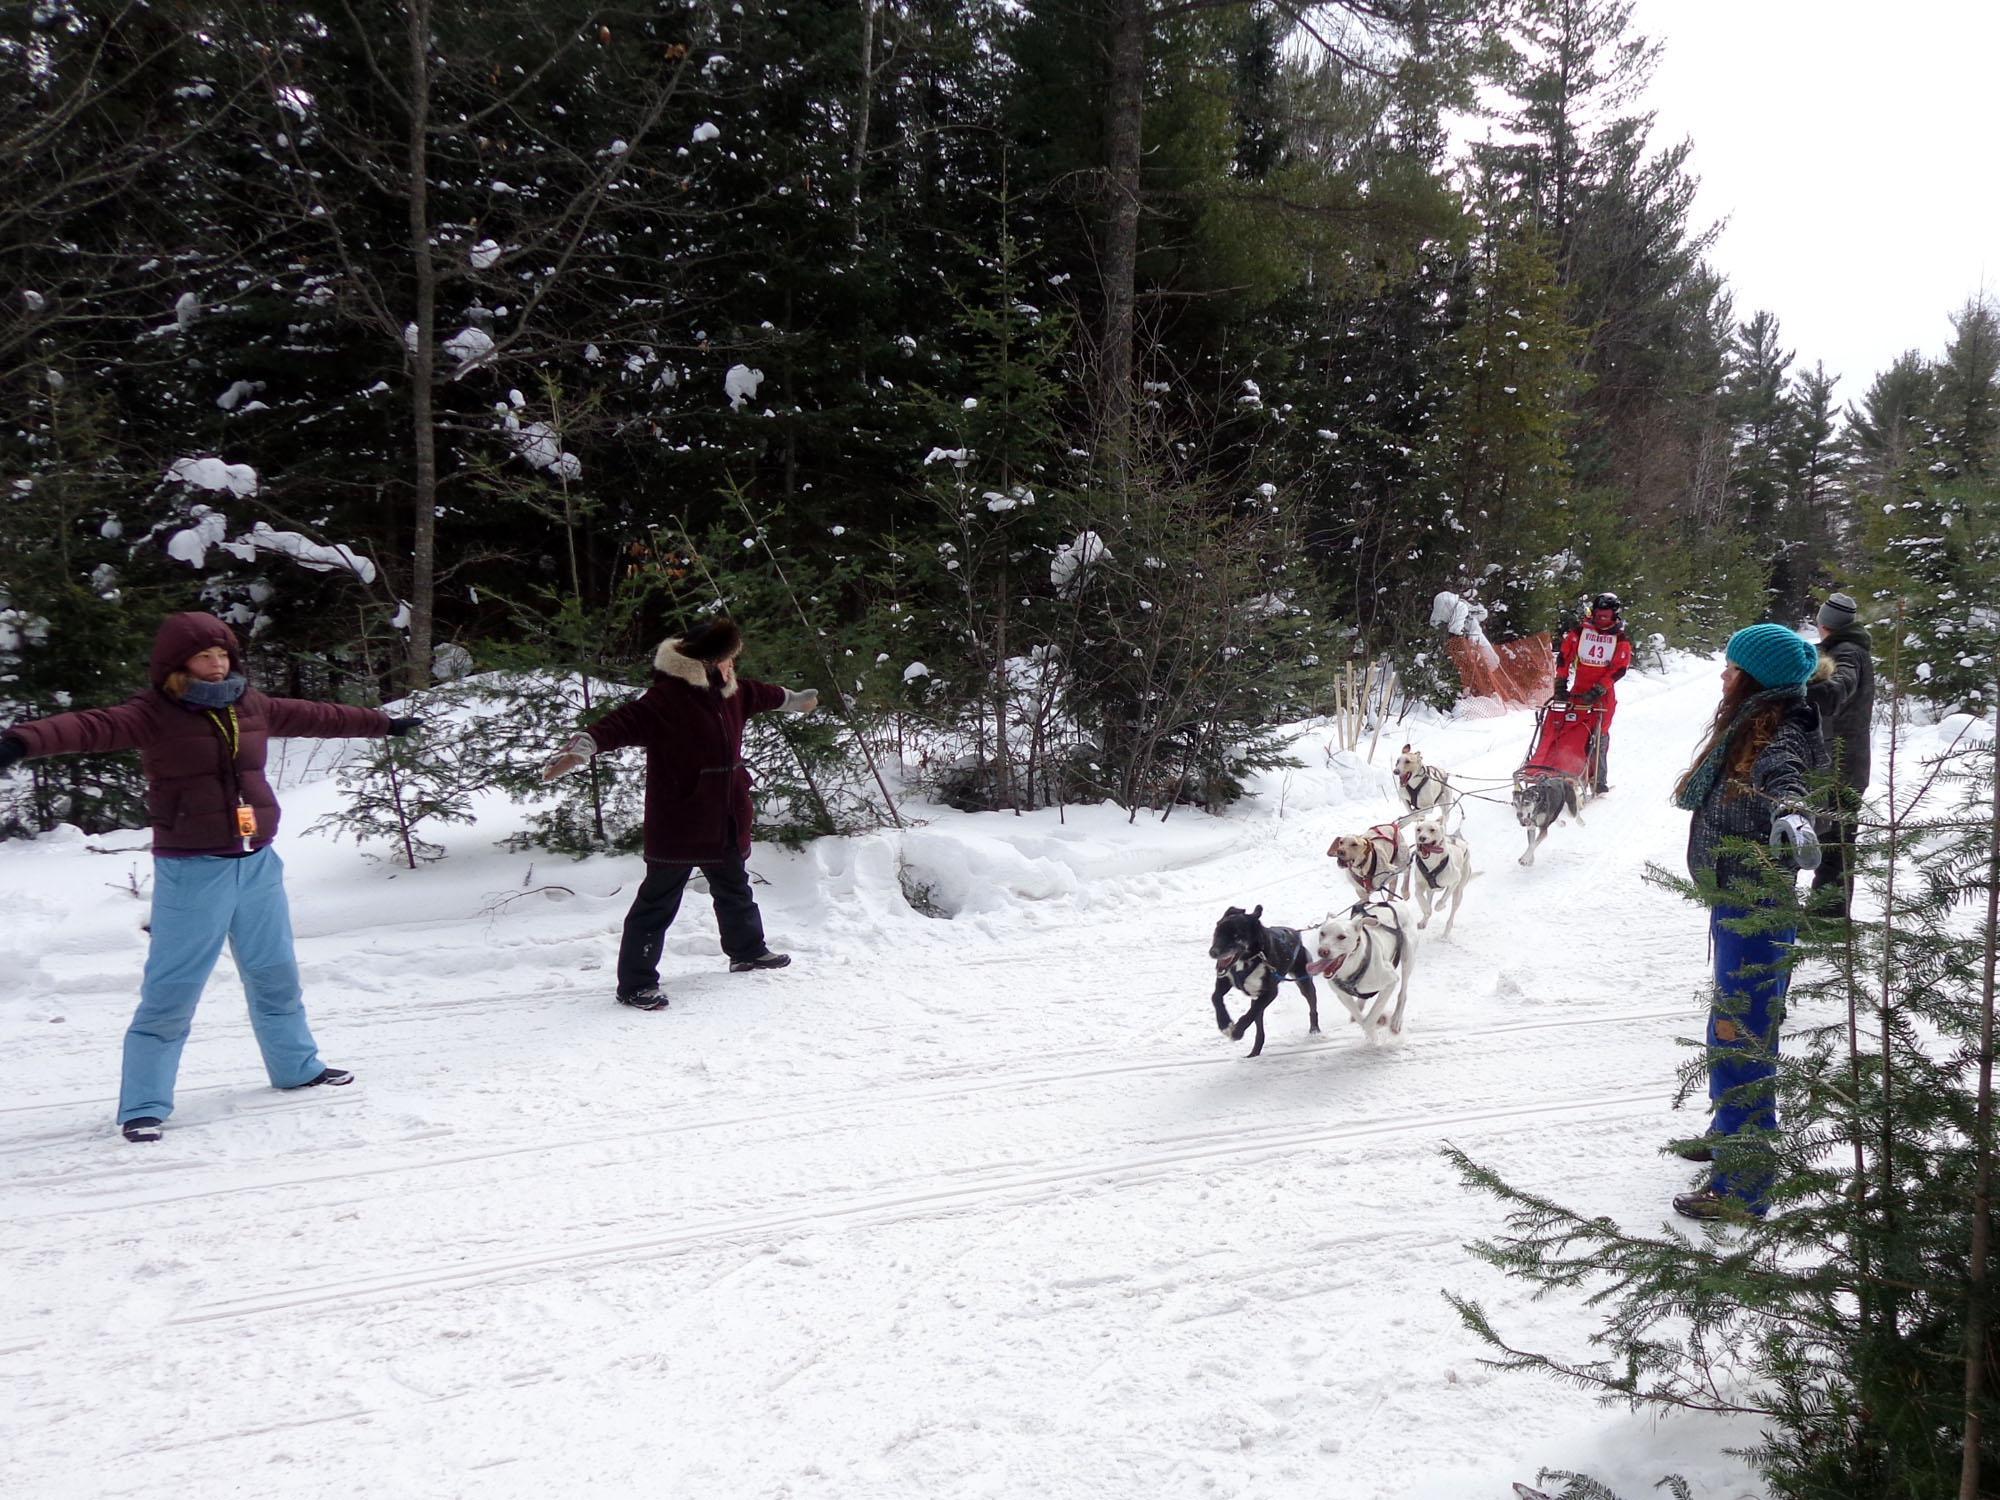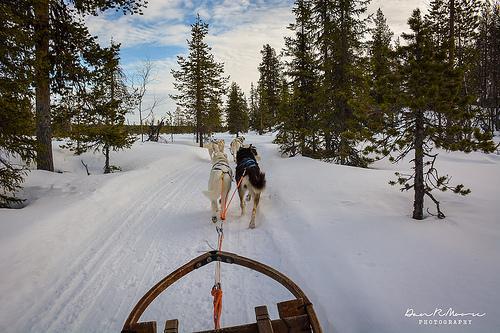The first image is the image on the left, the second image is the image on the right. Evaluate the accuracy of this statement regarding the images: "There are four people with their arms and legs spread to help the sled dogs run on the path.". Is it true? Answer yes or no. Yes. The first image is the image on the left, the second image is the image on the right. Evaluate the accuracy of this statement regarding the images: "Two people with outspread arms and spread legs are standing on the left as a sled dog team is coming down the trail.". Is it true? Answer yes or no. Yes. 